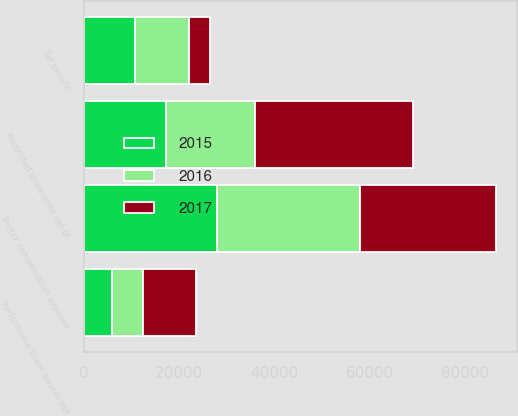Convert chart. <chart><loc_0><loc_0><loc_500><loc_500><stacked_bar_chart><ecel><fcel>Pretax compensation expense<fcel>Tax benefit<fcel>Restricted share units net of<fcel>Performance share awards net<nl><fcel>2017<fcel>28679<fcel>4385<fcel>33064<fcel>11082<nl><fcel>2016<fcel>29938<fcel>11347<fcel>18591<fcel>6637<nl><fcel>2015<fcel>27898<fcel>10629<fcel>17269<fcel>5775<nl></chart> 